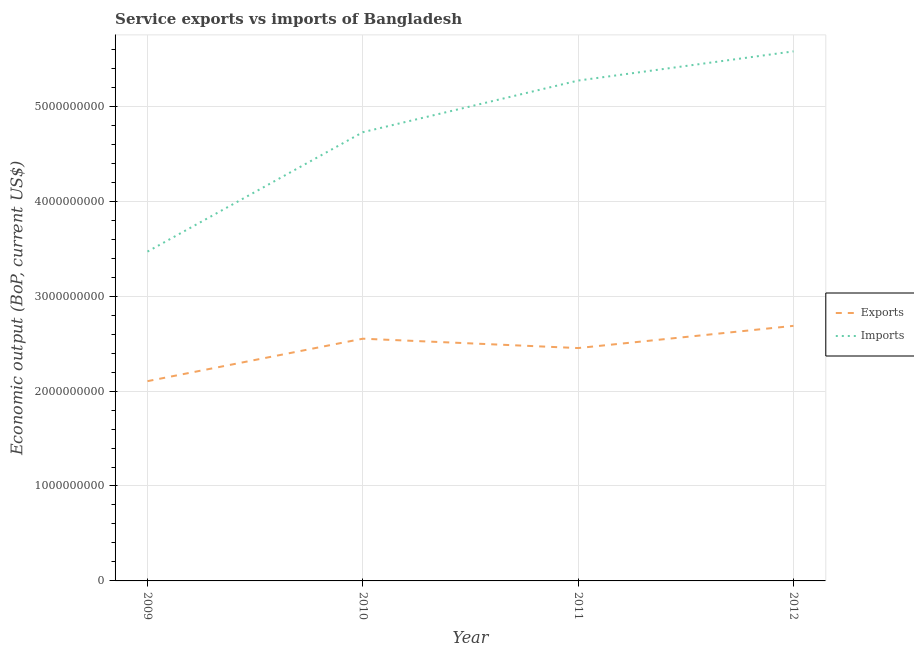Does the line corresponding to amount of service exports intersect with the line corresponding to amount of service imports?
Your answer should be very brief. No. Is the number of lines equal to the number of legend labels?
Provide a succinct answer. Yes. What is the amount of service imports in 2011?
Ensure brevity in your answer.  5.27e+09. Across all years, what is the maximum amount of service exports?
Provide a succinct answer. 2.69e+09. Across all years, what is the minimum amount of service exports?
Provide a succinct answer. 2.10e+09. In which year was the amount of service imports maximum?
Provide a short and direct response. 2012. What is the total amount of service imports in the graph?
Keep it short and to the point. 1.90e+1. What is the difference between the amount of service exports in 2010 and that in 2011?
Give a very brief answer. 9.87e+07. What is the difference between the amount of service imports in 2011 and the amount of service exports in 2009?
Offer a terse response. 3.17e+09. What is the average amount of service exports per year?
Offer a terse response. 2.45e+09. In the year 2012, what is the difference between the amount of service exports and amount of service imports?
Provide a short and direct response. -2.89e+09. In how many years, is the amount of service exports greater than 3400000000 US$?
Offer a terse response. 0. What is the ratio of the amount of service imports in 2010 to that in 2011?
Offer a very short reply. 0.9. Is the difference between the amount of service exports in 2010 and 2011 greater than the difference between the amount of service imports in 2010 and 2011?
Provide a succinct answer. Yes. What is the difference between the highest and the second highest amount of service imports?
Your answer should be compact. 3.08e+08. What is the difference between the highest and the lowest amount of service imports?
Ensure brevity in your answer.  2.11e+09. Is the sum of the amount of service imports in 2009 and 2011 greater than the maximum amount of service exports across all years?
Give a very brief answer. Yes. Is the amount of service exports strictly greater than the amount of service imports over the years?
Offer a very short reply. No. How many lines are there?
Your answer should be compact. 2. How many years are there in the graph?
Provide a short and direct response. 4. What is the difference between two consecutive major ticks on the Y-axis?
Ensure brevity in your answer.  1.00e+09. Are the values on the major ticks of Y-axis written in scientific E-notation?
Keep it short and to the point. No. Where does the legend appear in the graph?
Your answer should be compact. Center right. What is the title of the graph?
Keep it short and to the point. Service exports vs imports of Bangladesh. What is the label or title of the X-axis?
Ensure brevity in your answer.  Year. What is the label or title of the Y-axis?
Your answer should be compact. Economic output (BoP, current US$). What is the Economic output (BoP, current US$) of Exports in 2009?
Your response must be concise. 2.10e+09. What is the Economic output (BoP, current US$) in Imports in 2009?
Provide a short and direct response. 3.47e+09. What is the Economic output (BoP, current US$) of Exports in 2010?
Give a very brief answer. 2.55e+09. What is the Economic output (BoP, current US$) in Imports in 2010?
Keep it short and to the point. 4.73e+09. What is the Economic output (BoP, current US$) in Exports in 2011?
Give a very brief answer. 2.45e+09. What is the Economic output (BoP, current US$) in Imports in 2011?
Your answer should be compact. 5.27e+09. What is the Economic output (BoP, current US$) in Exports in 2012?
Provide a short and direct response. 2.69e+09. What is the Economic output (BoP, current US$) in Imports in 2012?
Your answer should be compact. 5.58e+09. Across all years, what is the maximum Economic output (BoP, current US$) in Exports?
Provide a short and direct response. 2.69e+09. Across all years, what is the maximum Economic output (BoP, current US$) of Imports?
Offer a terse response. 5.58e+09. Across all years, what is the minimum Economic output (BoP, current US$) of Exports?
Ensure brevity in your answer.  2.10e+09. Across all years, what is the minimum Economic output (BoP, current US$) in Imports?
Make the answer very short. 3.47e+09. What is the total Economic output (BoP, current US$) in Exports in the graph?
Give a very brief answer. 9.80e+09. What is the total Economic output (BoP, current US$) in Imports in the graph?
Make the answer very short. 1.90e+1. What is the difference between the Economic output (BoP, current US$) of Exports in 2009 and that in 2010?
Ensure brevity in your answer.  -4.47e+08. What is the difference between the Economic output (BoP, current US$) in Imports in 2009 and that in 2010?
Provide a short and direct response. -1.26e+09. What is the difference between the Economic output (BoP, current US$) of Exports in 2009 and that in 2011?
Offer a very short reply. -3.49e+08. What is the difference between the Economic output (BoP, current US$) in Imports in 2009 and that in 2011?
Offer a terse response. -1.80e+09. What is the difference between the Economic output (BoP, current US$) in Exports in 2009 and that in 2012?
Offer a terse response. -5.83e+08. What is the difference between the Economic output (BoP, current US$) of Imports in 2009 and that in 2012?
Your response must be concise. -2.11e+09. What is the difference between the Economic output (BoP, current US$) in Exports in 2010 and that in 2011?
Provide a short and direct response. 9.87e+07. What is the difference between the Economic output (BoP, current US$) in Imports in 2010 and that in 2011?
Provide a short and direct response. -5.44e+08. What is the difference between the Economic output (BoP, current US$) in Exports in 2010 and that in 2012?
Give a very brief answer. -1.35e+08. What is the difference between the Economic output (BoP, current US$) of Imports in 2010 and that in 2012?
Offer a terse response. -8.51e+08. What is the difference between the Economic output (BoP, current US$) in Exports in 2011 and that in 2012?
Provide a succinct answer. -2.34e+08. What is the difference between the Economic output (BoP, current US$) of Imports in 2011 and that in 2012?
Give a very brief answer. -3.08e+08. What is the difference between the Economic output (BoP, current US$) in Exports in 2009 and the Economic output (BoP, current US$) in Imports in 2010?
Provide a succinct answer. -2.62e+09. What is the difference between the Economic output (BoP, current US$) of Exports in 2009 and the Economic output (BoP, current US$) of Imports in 2011?
Ensure brevity in your answer.  -3.17e+09. What is the difference between the Economic output (BoP, current US$) of Exports in 2009 and the Economic output (BoP, current US$) of Imports in 2012?
Offer a very short reply. -3.47e+09. What is the difference between the Economic output (BoP, current US$) of Exports in 2010 and the Economic output (BoP, current US$) of Imports in 2011?
Offer a very short reply. -2.72e+09. What is the difference between the Economic output (BoP, current US$) of Exports in 2010 and the Economic output (BoP, current US$) of Imports in 2012?
Offer a terse response. -3.03e+09. What is the difference between the Economic output (BoP, current US$) of Exports in 2011 and the Economic output (BoP, current US$) of Imports in 2012?
Make the answer very short. -3.13e+09. What is the average Economic output (BoP, current US$) in Exports per year?
Your answer should be compact. 2.45e+09. What is the average Economic output (BoP, current US$) of Imports per year?
Provide a succinct answer. 4.76e+09. In the year 2009, what is the difference between the Economic output (BoP, current US$) in Exports and Economic output (BoP, current US$) in Imports?
Provide a succinct answer. -1.36e+09. In the year 2010, what is the difference between the Economic output (BoP, current US$) in Exports and Economic output (BoP, current US$) in Imports?
Your answer should be compact. -2.18e+09. In the year 2011, what is the difference between the Economic output (BoP, current US$) of Exports and Economic output (BoP, current US$) of Imports?
Offer a very short reply. -2.82e+09. In the year 2012, what is the difference between the Economic output (BoP, current US$) in Exports and Economic output (BoP, current US$) in Imports?
Provide a succinct answer. -2.89e+09. What is the ratio of the Economic output (BoP, current US$) in Exports in 2009 to that in 2010?
Give a very brief answer. 0.82. What is the ratio of the Economic output (BoP, current US$) in Imports in 2009 to that in 2010?
Give a very brief answer. 0.73. What is the ratio of the Economic output (BoP, current US$) of Exports in 2009 to that in 2011?
Your answer should be compact. 0.86. What is the ratio of the Economic output (BoP, current US$) of Imports in 2009 to that in 2011?
Offer a very short reply. 0.66. What is the ratio of the Economic output (BoP, current US$) of Exports in 2009 to that in 2012?
Ensure brevity in your answer.  0.78. What is the ratio of the Economic output (BoP, current US$) in Imports in 2009 to that in 2012?
Keep it short and to the point. 0.62. What is the ratio of the Economic output (BoP, current US$) of Exports in 2010 to that in 2011?
Make the answer very short. 1.04. What is the ratio of the Economic output (BoP, current US$) of Imports in 2010 to that in 2011?
Your response must be concise. 0.9. What is the ratio of the Economic output (BoP, current US$) of Exports in 2010 to that in 2012?
Provide a succinct answer. 0.95. What is the ratio of the Economic output (BoP, current US$) in Imports in 2010 to that in 2012?
Your answer should be very brief. 0.85. What is the ratio of the Economic output (BoP, current US$) of Exports in 2011 to that in 2012?
Offer a very short reply. 0.91. What is the ratio of the Economic output (BoP, current US$) in Imports in 2011 to that in 2012?
Offer a very short reply. 0.94. What is the difference between the highest and the second highest Economic output (BoP, current US$) in Exports?
Give a very brief answer. 1.35e+08. What is the difference between the highest and the second highest Economic output (BoP, current US$) of Imports?
Ensure brevity in your answer.  3.08e+08. What is the difference between the highest and the lowest Economic output (BoP, current US$) of Exports?
Give a very brief answer. 5.83e+08. What is the difference between the highest and the lowest Economic output (BoP, current US$) of Imports?
Provide a succinct answer. 2.11e+09. 